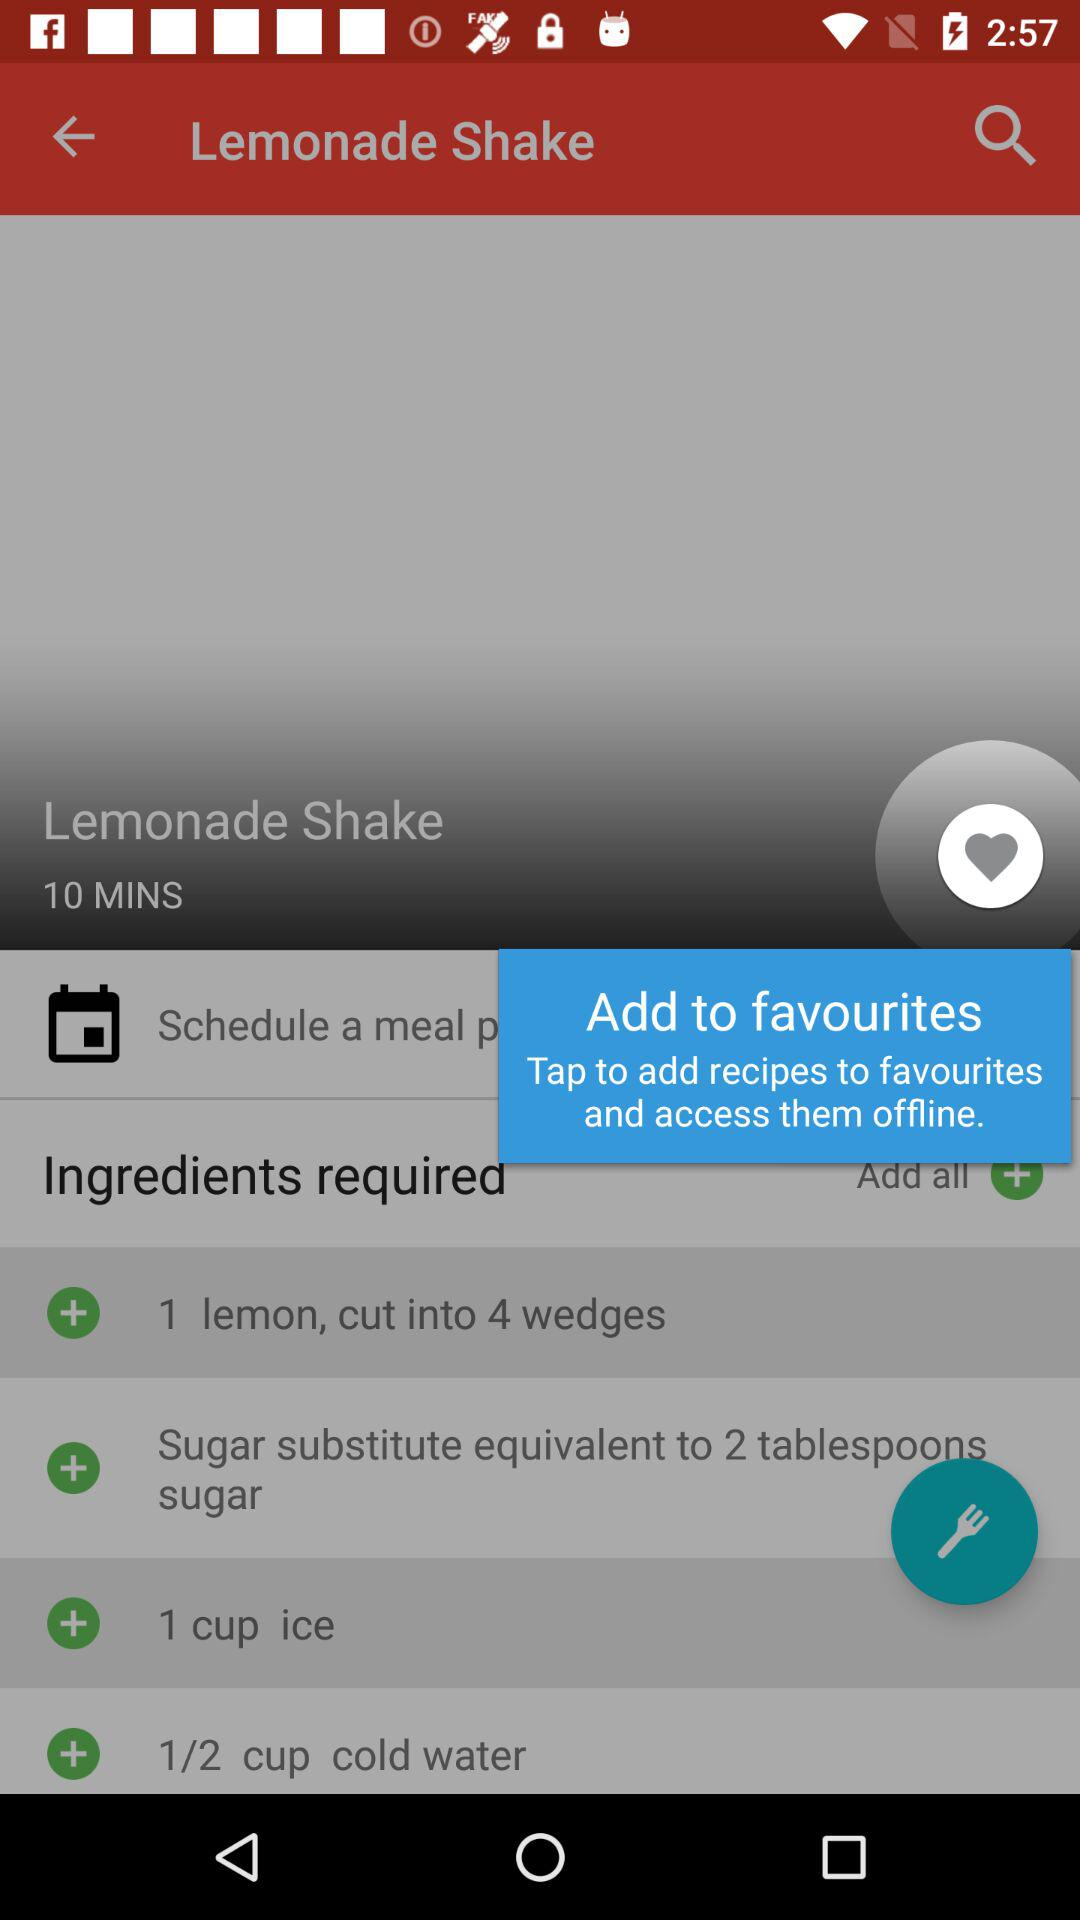How many cups of ice are required to make a lemonade shake? The ice required is 1 cup. 